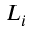<formula> <loc_0><loc_0><loc_500><loc_500>L _ { i }</formula> 